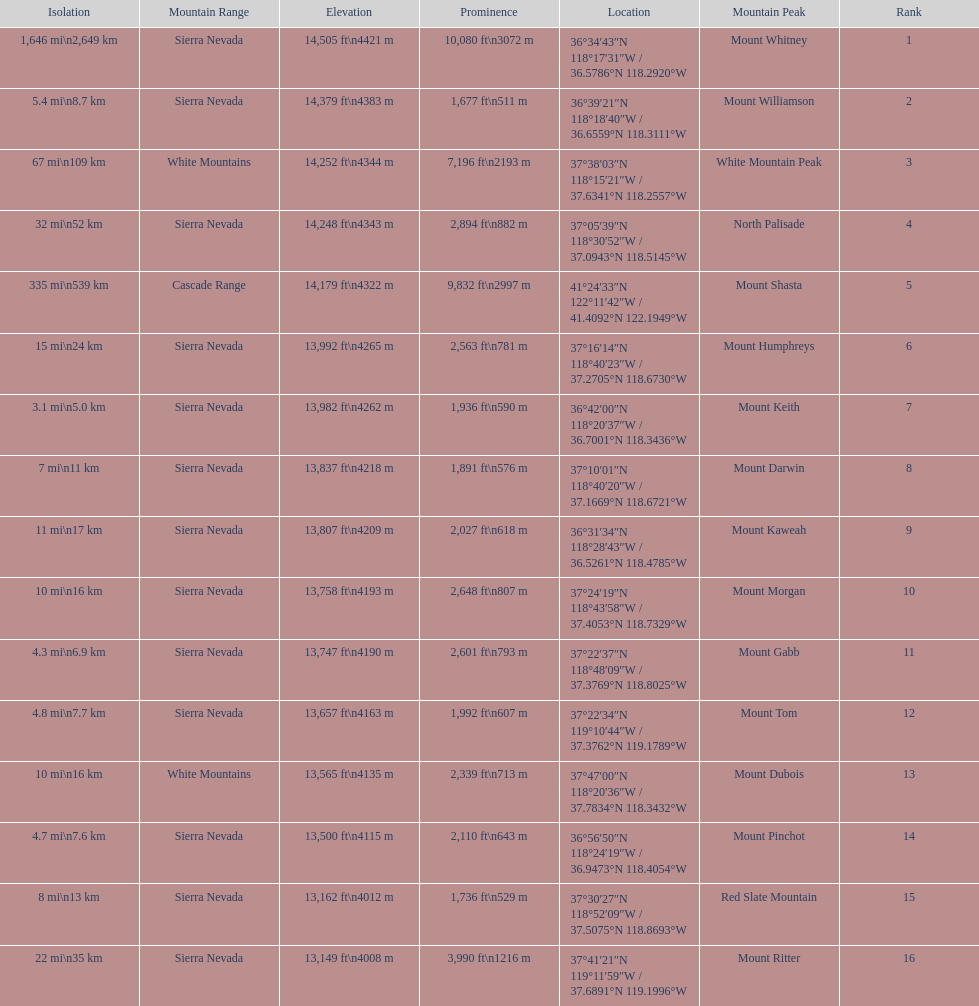In feet, what is the difference between the tallest peak and the 9th tallest peak in california? 698 ft. 